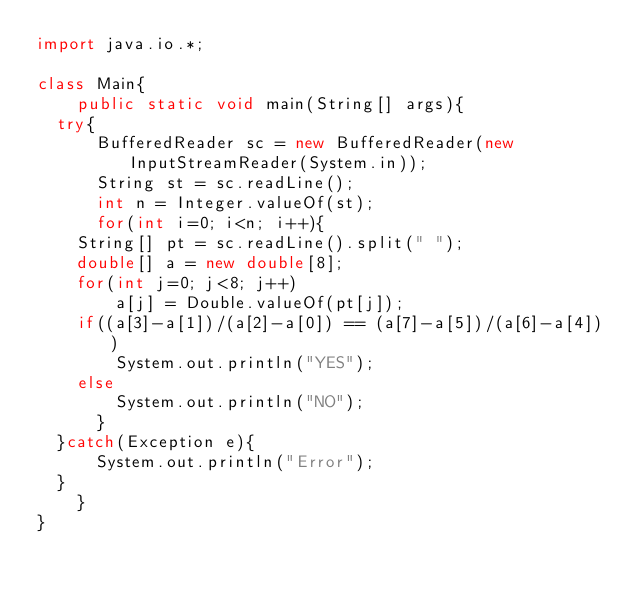Convert code to text. <code><loc_0><loc_0><loc_500><loc_500><_Java_>import java.io.*;

class Main{
    public static void main(String[] args){
	try{
	    BufferedReader sc = new BufferedReader(new InputStreamReader(System.in));
	    String st = sc.readLine();
	    int n = Integer.valueOf(st);
	    for(int i=0; i<n; i++){
		String[] pt = sc.readLine().split(" ");
		double[] a = new double[8];
		for(int j=0; j<8; j++)
		    a[j] = Double.valueOf(pt[j]);
		if((a[3]-a[1])/(a[2]-a[0]) == (a[7]-a[5])/(a[6]-a[4]))
		    System.out.println("YES");
		else
		    System.out.println("NO");
	    }
	}catch(Exception e){
	    System.out.println("Error");
	}
    }
}</code> 